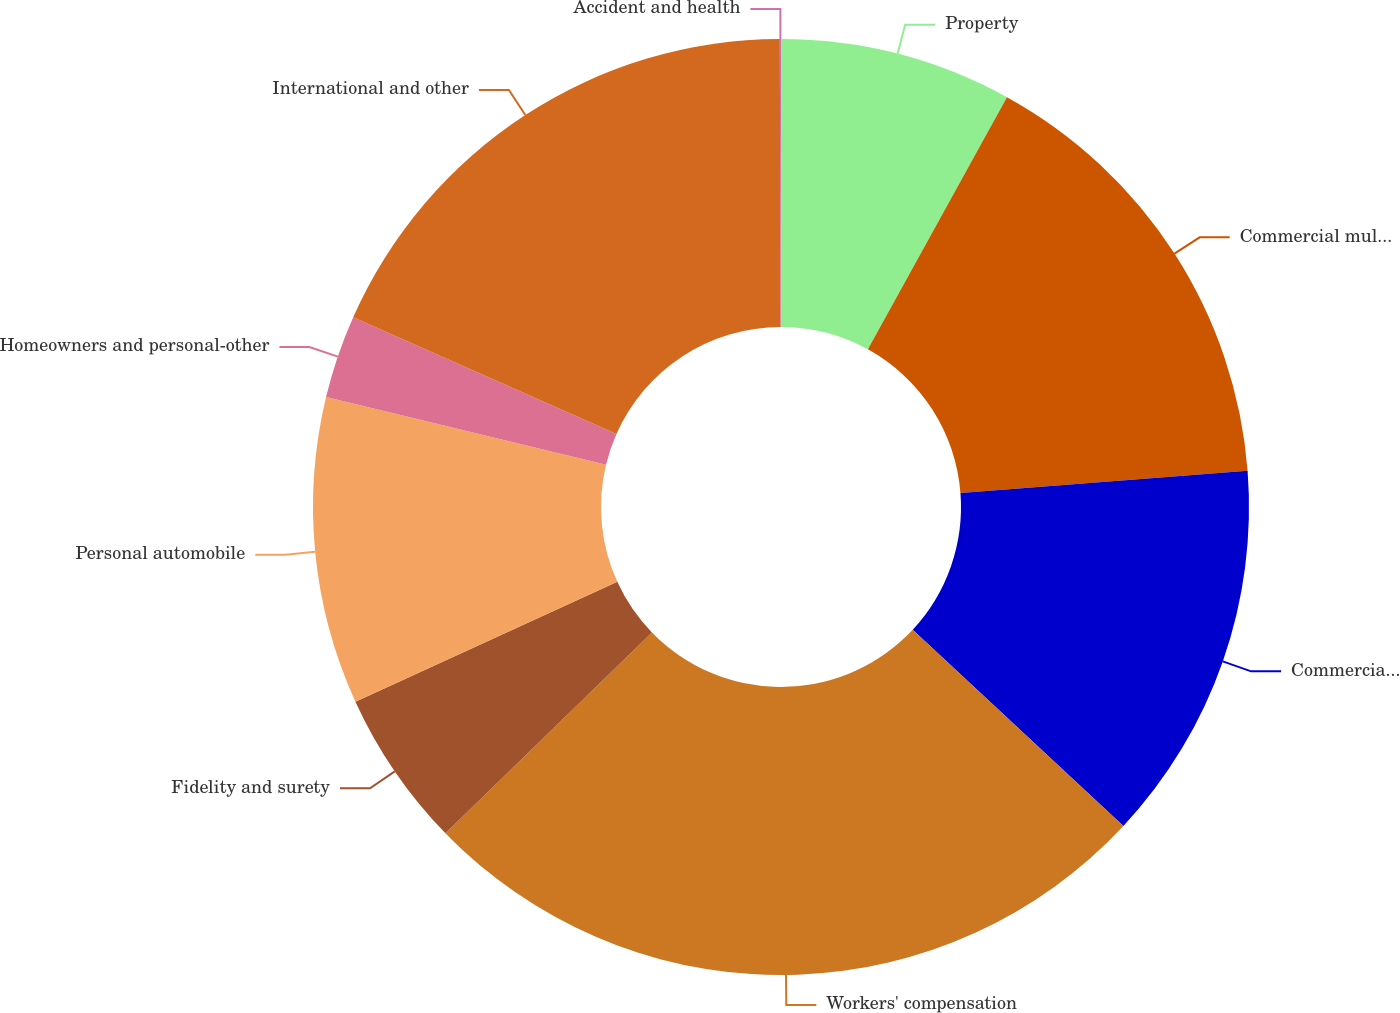<chart> <loc_0><loc_0><loc_500><loc_500><pie_chart><fcel>Property<fcel>Commercial multi-peril<fcel>Commercial automobile<fcel>Workers' compensation<fcel>Fidelity and surety<fcel>Personal automobile<fcel>Homeowners and personal-other<fcel>International and other<fcel>Accident and health<nl><fcel>8.02%<fcel>15.75%<fcel>13.17%<fcel>25.79%<fcel>5.45%<fcel>10.6%<fcel>2.87%<fcel>18.32%<fcel>0.04%<nl></chart> 